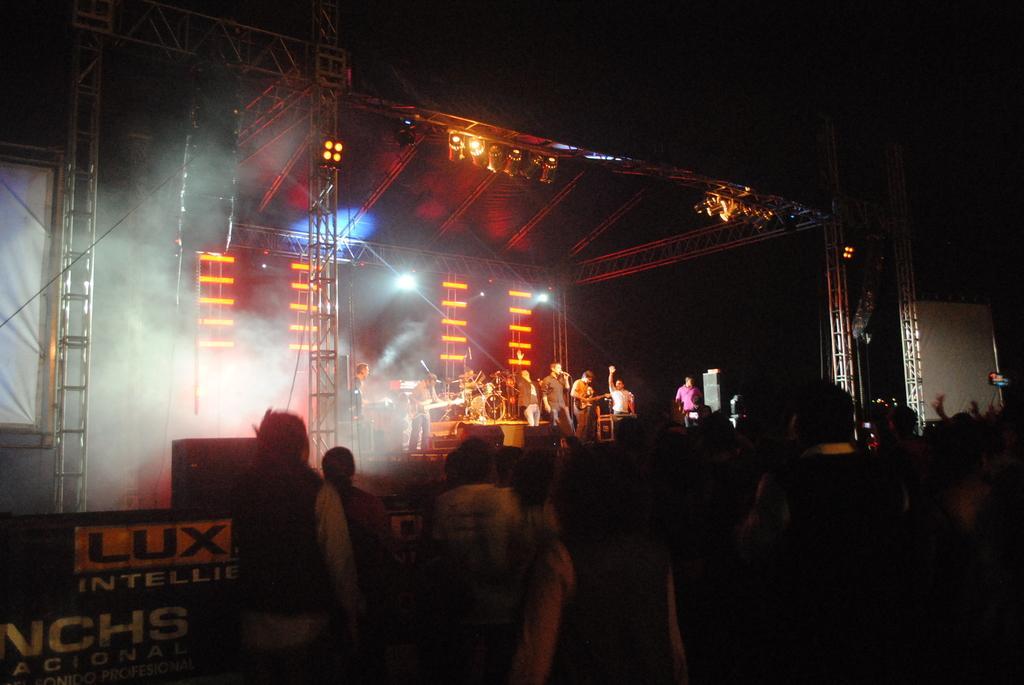Please provide a concise description of this image. In this picture we can see some people are standing on the path and some people are standing on the stage. The people on the stage holding some musical instruments. At the top there are lights. On the left side of the people there is a board, cable and some objects. Behind the people there is a dark background. 